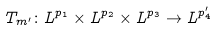<formula> <loc_0><loc_0><loc_500><loc_500>T _ { m ^ { \prime } } \colon L ^ { p _ { 1 } } \times L ^ { p _ { 2 } } \times L ^ { p _ { 3 } } \rightarrow L ^ { p ^ { \prime } _ { 4 } }</formula> 